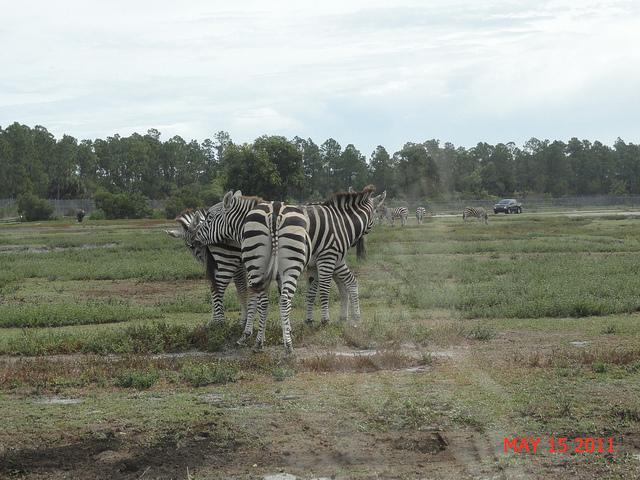What animal is most similar to these? horse 